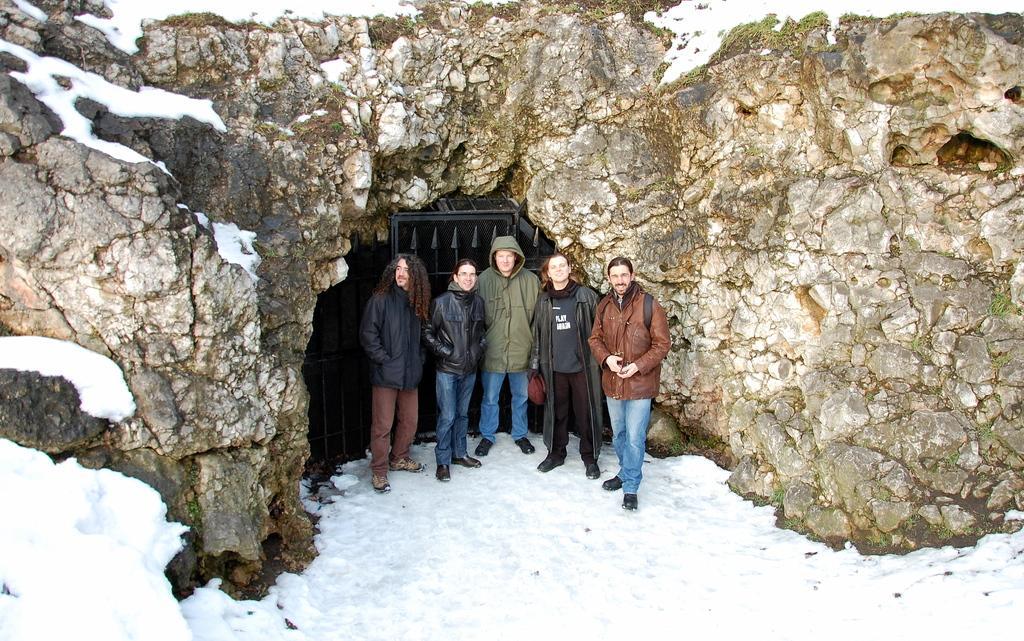Describe this image in one or two sentences. In the image there is a huge rock surface and under that rock surface there is a gate in front of a cave, a group of people were standing in front of a cave and the ground is surrounded with a lot of snow. 